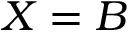<formula> <loc_0><loc_0><loc_500><loc_500>X = B</formula> 